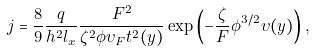<formula> <loc_0><loc_0><loc_500><loc_500>j = \frac { 8 } { 9 } \frac { q } { h ^ { 2 } l _ { x } } \frac { F ^ { 2 } } { \zeta ^ { 2 } \phi \upsilon _ { F } t ^ { 2 } ( y ) } \exp \left ( - \frac { \zeta } { F } \phi ^ { 3 / 2 } \upsilon ( y ) \right ) ,</formula> 